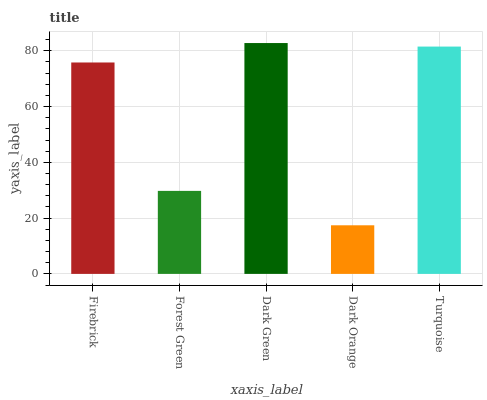Is Dark Orange the minimum?
Answer yes or no. Yes. Is Dark Green the maximum?
Answer yes or no. Yes. Is Forest Green the minimum?
Answer yes or no. No. Is Forest Green the maximum?
Answer yes or no. No. Is Firebrick greater than Forest Green?
Answer yes or no. Yes. Is Forest Green less than Firebrick?
Answer yes or no. Yes. Is Forest Green greater than Firebrick?
Answer yes or no. No. Is Firebrick less than Forest Green?
Answer yes or no. No. Is Firebrick the high median?
Answer yes or no. Yes. Is Firebrick the low median?
Answer yes or no. Yes. Is Forest Green the high median?
Answer yes or no. No. Is Turquoise the low median?
Answer yes or no. No. 